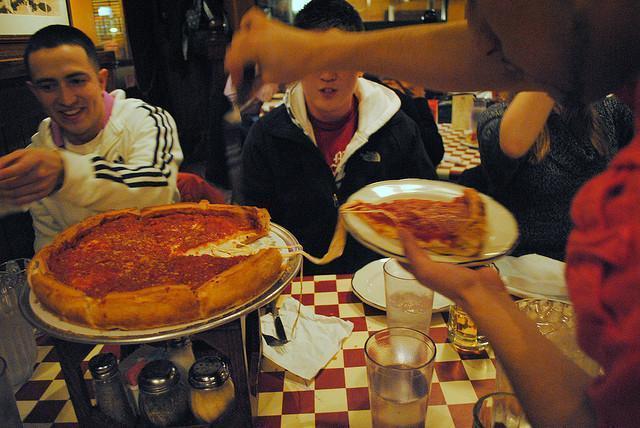How many shakers of condiments do you see?
Give a very brief answer. 3. How many bottles are in the photo?
Give a very brief answer. 3. How many dining tables can you see?
Give a very brief answer. 1. How many pizzas can you see?
Give a very brief answer. 2. How many people are there?
Give a very brief answer. 5. How many cups are there?
Give a very brief answer. 2. How many people are wearing a tie in the picture?
Give a very brief answer. 0. 